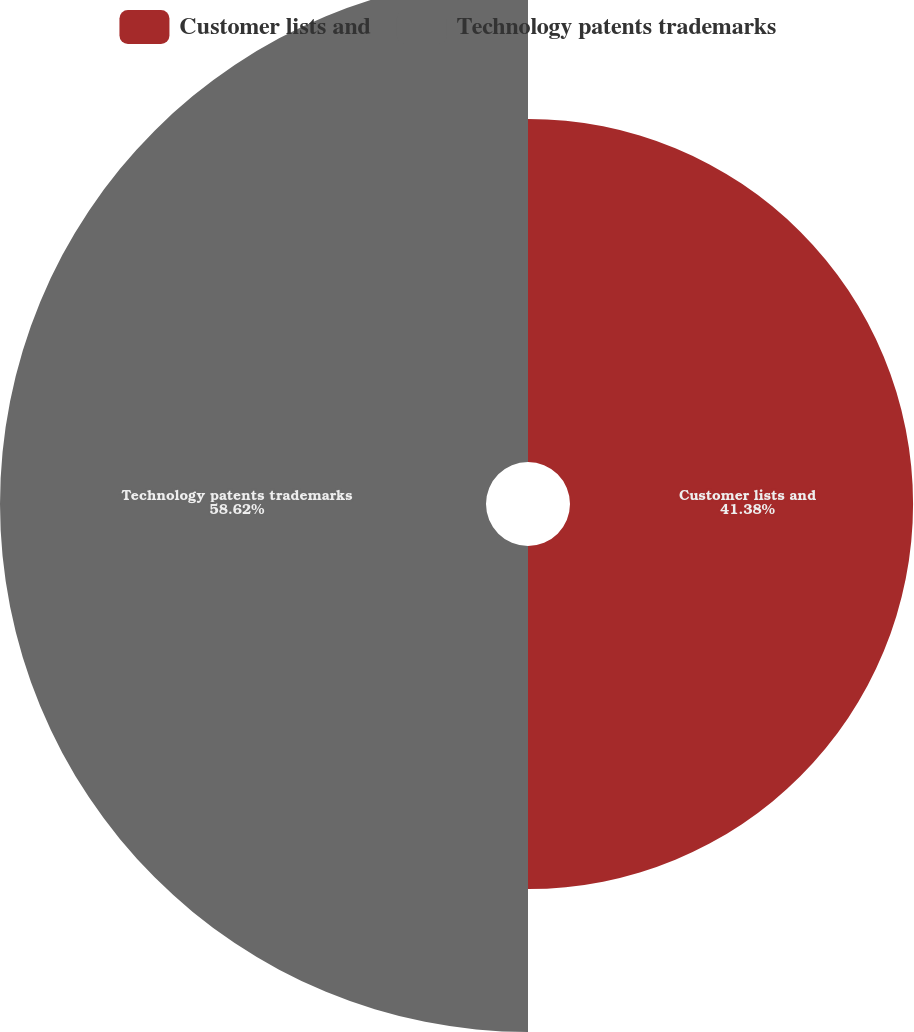Convert chart to OTSL. <chart><loc_0><loc_0><loc_500><loc_500><pie_chart><fcel>Customer lists and<fcel>Technology patents trademarks<nl><fcel>41.38%<fcel>58.62%<nl></chart> 